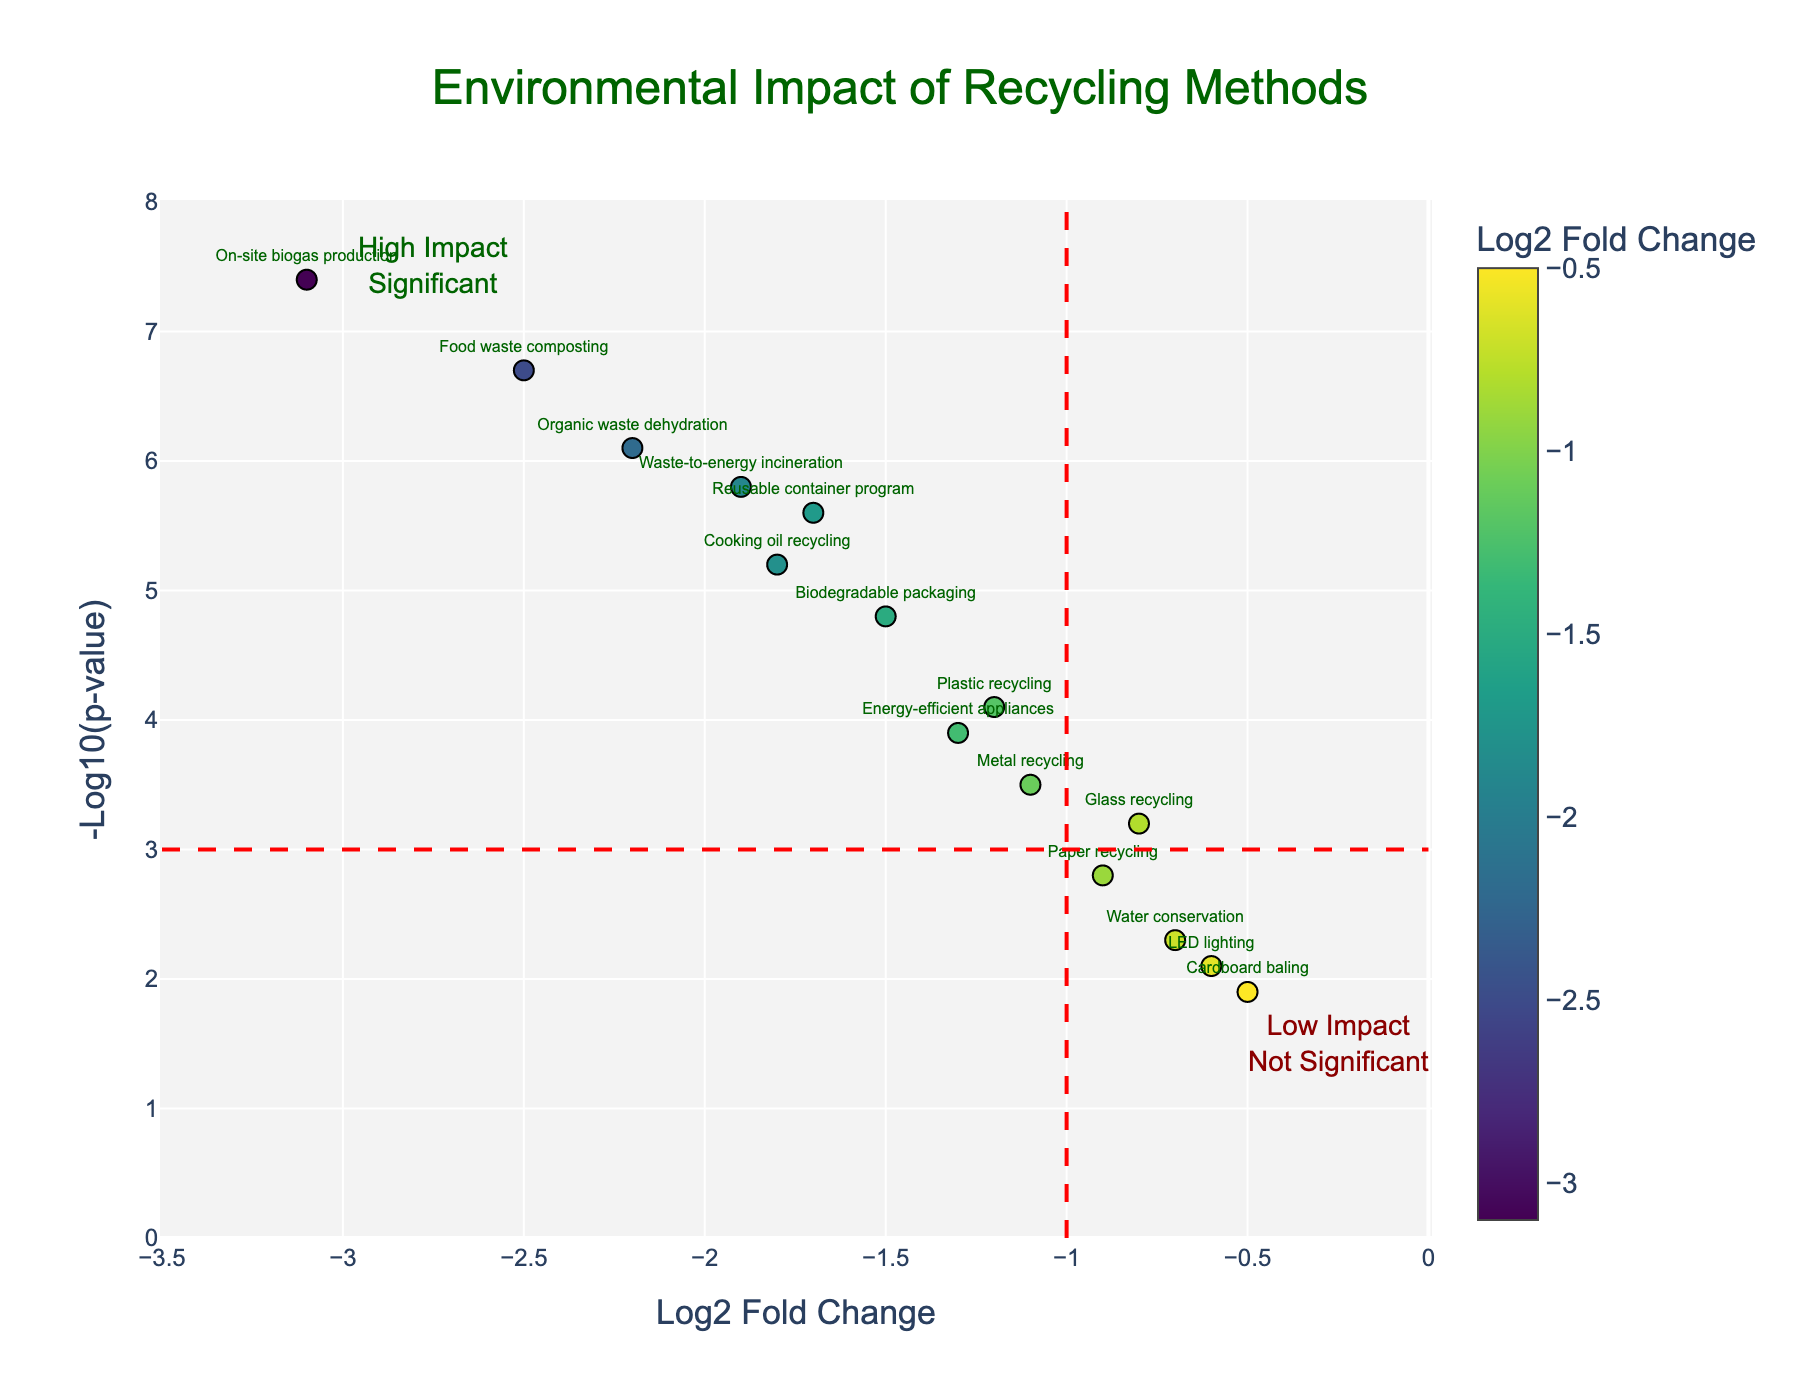What is the title of the plot? The title of the plot is typically displayed at the top center of the figure. It provides a summary of what the plot represents. In this case, the title is "Environmental Impact of Recycling Methods".
Answer: Environmental Impact of Recycling Methods What are the x-axis and y-axis labels in the figure? The x-axis and y-axis labels are used to describe what the axes represent. From the figure, the x-axis is labeled "Log2 Fold Change" and the y-axis is labeled "-Log10(p-value)".
Answer: Log2 Fold Change and -Log10(p-value) How many data points are above the horizontal red dashed line (p-value threshold)? Data points above the red dashed line located at -Log10(p-value) = 3 are considered significant. By counting the points above this threshold, we see there are 10 such points.
Answer: 10 Which recycling method has the highest significance based on p-value? The method with the highest significance will be the one with the largest -Log10(p-value). From the plot, "On-site biogas production" has the highest -Log10(p-value) of 7.4, making it the most significant.
Answer: On-site biogas production Which method shows the greatest carbon footprint reduction? The method with the greatest reduction will have the most negative Log2 Fold Change. "On-site biogas production" has the most negative value at -3.1, indicating the greatest carbon footprint reduction.
Answer: On-site biogas production Compare "Reusable container program" and "Cooking oil recycling" in terms of significance and fold change. Which method is more significant and which one has a higher carbon footprint reduction? To determine significance, compare their -Log10(p-values). Reusable container program: 5.6, Cooking oil recycling: 5.2. Reusable container program is more significant. For fold change, compare their Log2 Fold Change. Reusable container program: -1.7, Cooking oil recycling: -1.8. Cooking oil recycling has a slightly higher (more negative) carbon footprint reduction.
Answer: Reusable container program is more significant; Cooking oil recycling has higher reduction What does the annotation "High Impact Significant" refer to in the plot? This annotation is typically positioned in a region where data points have low Log2 Fold Change and high -Log10(p-value). It suggests that methods in this area have significant and high environmental impact. Located near -2.75 on x-axis and 7.5 on y-axis.
Answer: Methods with high significance and high environmental impact Is there any method that is not significant and also shows low impact? Methods that are not significant lie below the horizontal red dashed line, and methods with low impact will have a Log2 Fold Change close to 0. "Cardboard baling" meets both criteria as it is below the line and has a Log2 Fold Change of -0.5.
Answer: Cardboard baling Which methods fall within the "Low Impact Not Significant" quadrant of the plot? Methods in this quadrant will be to the right of the vertical red line (Log2 Fold Change > -1) and below the horizontal red line (-Log10(p-value) < 3). "Cardboard baling" and "LED lighting" are in this quadrant.
Answer: Cardboard baling and LED lighting What is the approximate p-value for the "Water conservation" method? The p-value can be inferred from the -Log10(p-value). For "Water conservation," the -Log10(p-value) is approximately 2.3. Converting, the p-value is 10^(-2.3). Using a calculator, 10^(-2.3) ≈ 0.005.
Answer: Approximately 0.005 